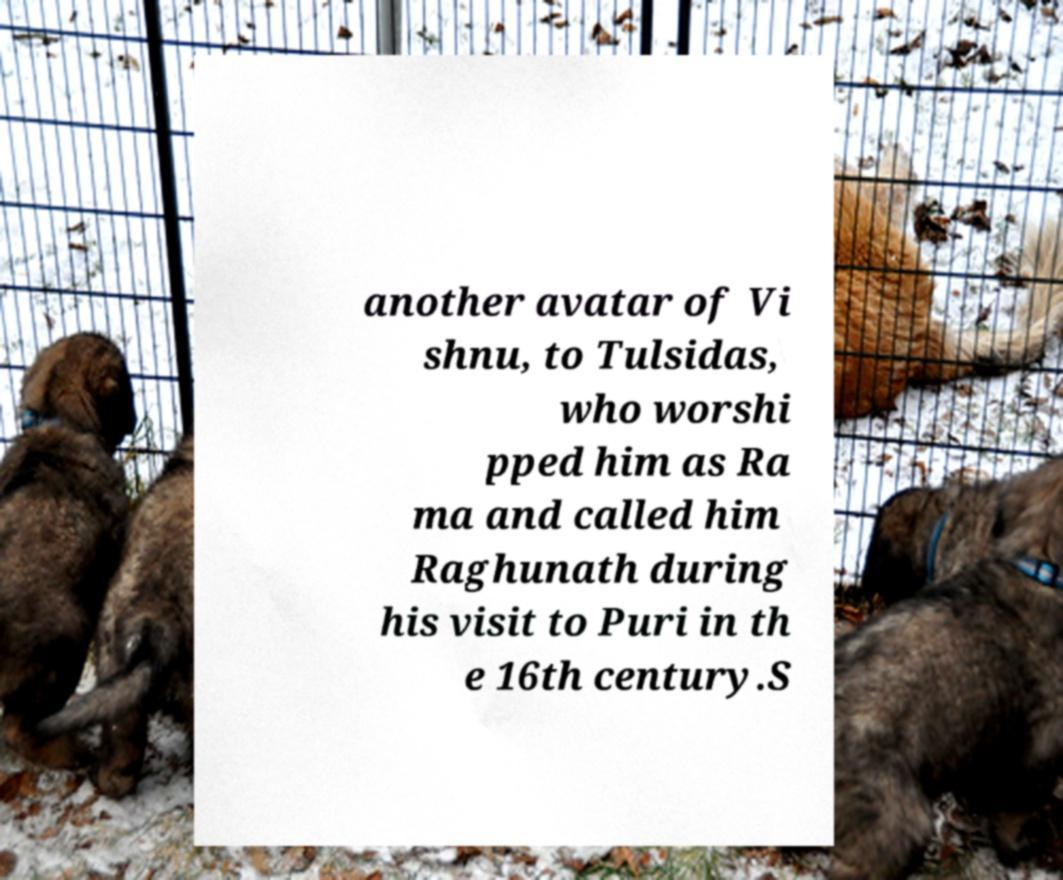What messages or text are displayed in this image? I need them in a readable, typed format. another avatar of Vi shnu, to Tulsidas, who worshi pped him as Ra ma and called him Raghunath during his visit to Puri in th e 16th century.S 